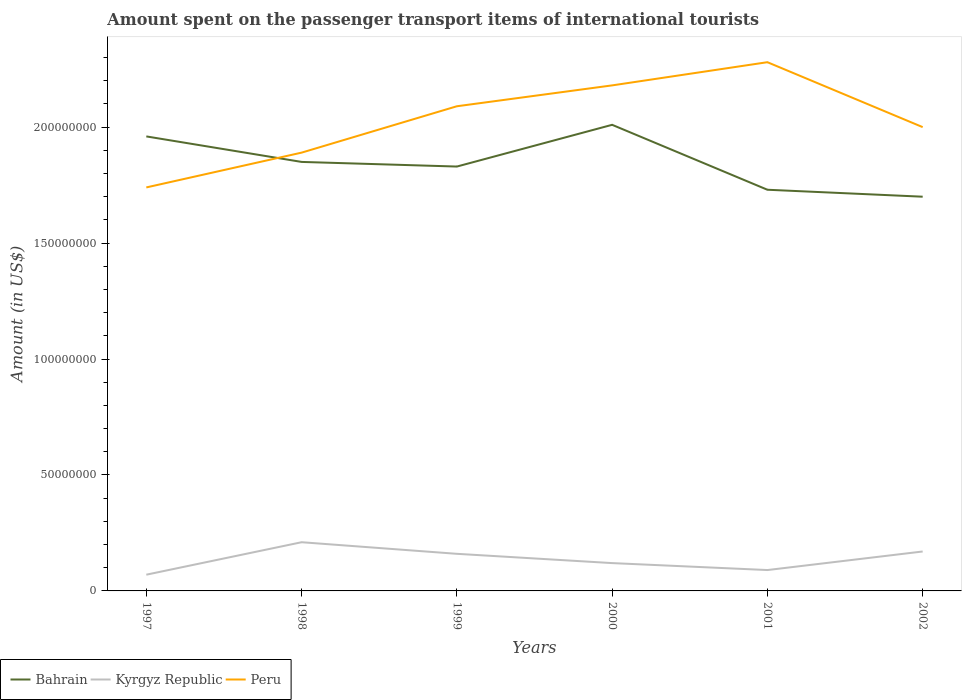How many different coloured lines are there?
Make the answer very short. 3. Does the line corresponding to Bahrain intersect with the line corresponding to Kyrgyz Republic?
Your answer should be very brief. No. Is the number of lines equal to the number of legend labels?
Provide a succinct answer. Yes. Across all years, what is the maximum amount spent on the passenger transport items of international tourists in Peru?
Keep it short and to the point. 1.74e+08. In which year was the amount spent on the passenger transport items of international tourists in Kyrgyz Republic maximum?
Your answer should be very brief. 1997. What is the total amount spent on the passenger transport items of international tourists in Bahrain in the graph?
Your answer should be very brief. 3.10e+07. What is the difference between the highest and the second highest amount spent on the passenger transport items of international tourists in Bahrain?
Your answer should be very brief. 3.10e+07. What is the difference between the highest and the lowest amount spent on the passenger transport items of international tourists in Kyrgyz Republic?
Your answer should be very brief. 3. How many lines are there?
Provide a succinct answer. 3. Are the values on the major ticks of Y-axis written in scientific E-notation?
Your answer should be very brief. No. Does the graph contain any zero values?
Your answer should be very brief. No. Does the graph contain grids?
Provide a short and direct response. No. How many legend labels are there?
Make the answer very short. 3. What is the title of the graph?
Your response must be concise. Amount spent on the passenger transport items of international tourists. Does "Tanzania" appear as one of the legend labels in the graph?
Make the answer very short. No. What is the label or title of the X-axis?
Your response must be concise. Years. What is the label or title of the Y-axis?
Offer a very short reply. Amount (in US$). What is the Amount (in US$) in Bahrain in 1997?
Offer a terse response. 1.96e+08. What is the Amount (in US$) of Kyrgyz Republic in 1997?
Give a very brief answer. 7.00e+06. What is the Amount (in US$) in Peru in 1997?
Give a very brief answer. 1.74e+08. What is the Amount (in US$) of Bahrain in 1998?
Your response must be concise. 1.85e+08. What is the Amount (in US$) in Kyrgyz Republic in 1998?
Ensure brevity in your answer.  2.10e+07. What is the Amount (in US$) in Peru in 1998?
Make the answer very short. 1.89e+08. What is the Amount (in US$) in Bahrain in 1999?
Give a very brief answer. 1.83e+08. What is the Amount (in US$) of Kyrgyz Republic in 1999?
Make the answer very short. 1.60e+07. What is the Amount (in US$) in Peru in 1999?
Offer a very short reply. 2.09e+08. What is the Amount (in US$) in Bahrain in 2000?
Ensure brevity in your answer.  2.01e+08. What is the Amount (in US$) of Kyrgyz Republic in 2000?
Your answer should be compact. 1.20e+07. What is the Amount (in US$) of Peru in 2000?
Your answer should be very brief. 2.18e+08. What is the Amount (in US$) in Bahrain in 2001?
Your answer should be compact. 1.73e+08. What is the Amount (in US$) of Kyrgyz Republic in 2001?
Provide a short and direct response. 9.00e+06. What is the Amount (in US$) of Peru in 2001?
Offer a very short reply. 2.28e+08. What is the Amount (in US$) of Bahrain in 2002?
Offer a terse response. 1.70e+08. What is the Amount (in US$) of Kyrgyz Republic in 2002?
Provide a succinct answer. 1.70e+07. Across all years, what is the maximum Amount (in US$) of Bahrain?
Ensure brevity in your answer.  2.01e+08. Across all years, what is the maximum Amount (in US$) in Kyrgyz Republic?
Your answer should be compact. 2.10e+07. Across all years, what is the maximum Amount (in US$) of Peru?
Keep it short and to the point. 2.28e+08. Across all years, what is the minimum Amount (in US$) of Bahrain?
Your answer should be compact. 1.70e+08. Across all years, what is the minimum Amount (in US$) of Peru?
Give a very brief answer. 1.74e+08. What is the total Amount (in US$) of Bahrain in the graph?
Ensure brevity in your answer.  1.11e+09. What is the total Amount (in US$) in Kyrgyz Republic in the graph?
Offer a very short reply. 8.20e+07. What is the total Amount (in US$) in Peru in the graph?
Ensure brevity in your answer.  1.22e+09. What is the difference between the Amount (in US$) in Bahrain in 1997 and that in 1998?
Offer a very short reply. 1.10e+07. What is the difference between the Amount (in US$) of Kyrgyz Republic in 1997 and that in 1998?
Your response must be concise. -1.40e+07. What is the difference between the Amount (in US$) in Peru in 1997 and that in 1998?
Ensure brevity in your answer.  -1.50e+07. What is the difference between the Amount (in US$) of Bahrain in 1997 and that in 1999?
Your answer should be compact. 1.30e+07. What is the difference between the Amount (in US$) in Kyrgyz Republic in 1997 and that in 1999?
Provide a short and direct response. -9.00e+06. What is the difference between the Amount (in US$) of Peru in 1997 and that in 1999?
Your response must be concise. -3.50e+07. What is the difference between the Amount (in US$) of Bahrain in 1997 and that in 2000?
Your response must be concise. -5.00e+06. What is the difference between the Amount (in US$) in Kyrgyz Republic in 1997 and that in 2000?
Offer a very short reply. -5.00e+06. What is the difference between the Amount (in US$) in Peru in 1997 and that in 2000?
Keep it short and to the point. -4.40e+07. What is the difference between the Amount (in US$) in Bahrain in 1997 and that in 2001?
Ensure brevity in your answer.  2.30e+07. What is the difference between the Amount (in US$) of Peru in 1997 and that in 2001?
Keep it short and to the point. -5.40e+07. What is the difference between the Amount (in US$) in Bahrain in 1997 and that in 2002?
Make the answer very short. 2.60e+07. What is the difference between the Amount (in US$) of Kyrgyz Republic in 1997 and that in 2002?
Offer a very short reply. -1.00e+07. What is the difference between the Amount (in US$) of Peru in 1997 and that in 2002?
Offer a very short reply. -2.60e+07. What is the difference between the Amount (in US$) in Peru in 1998 and that in 1999?
Your answer should be compact. -2.00e+07. What is the difference between the Amount (in US$) of Bahrain in 1998 and that in 2000?
Ensure brevity in your answer.  -1.60e+07. What is the difference between the Amount (in US$) in Kyrgyz Republic in 1998 and that in 2000?
Offer a terse response. 9.00e+06. What is the difference between the Amount (in US$) in Peru in 1998 and that in 2000?
Keep it short and to the point. -2.90e+07. What is the difference between the Amount (in US$) of Peru in 1998 and that in 2001?
Provide a short and direct response. -3.90e+07. What is the difference between the Amount (in US$) of Bahrain in 1998 and that in 2002?
Make the answer very short. 1.50e+07. What is the difference between the Amount (in US$) in Peru in 1998 and that in 2002?
Provide a succinct answer. -1.10e+07. What is the difference between the Amount (in US$) of Bahrain in 1999 and that in 2000?
Your response must be concise. -1.80e+07. What is the difference between the Amount (in US$) of Peru in 1999 and that in 2000?
Offer a very short reply. -9.00e+06. What is the difference between the Amount (in US$) in Kyrgyz Republic in 1999 and that in 2001?
Make the answer very short. 7.00e+06. What is the difference between the Amount (in US$) in Peru in 1999 and that in 2001?
Keep it short and to the point. -1.90e+07. What is the difference between the Amount (in US$) in Bahrain in 1999 and that in 2002?
Offer a very short reply. 1.30e+07. What is the difference between the Amount (in US$) in Peru in 1999 and that in 2002?
Your answer should be very brief. 9.00e+06. What is the difference between the Amount (in US$) in Bahrain in 2000 and that in 2001?
Your response must be concise. 2.80e+07. What is the difference between the Amount (in US$) of Kyrgyz Republic in 2000 and that in 2001?
Keep it short and to the point. 3.00e+06. What is the difference between the Amount (in US$) of Peru in 2000 and that in 2001?
Your response must be concise. -1.00e+07. What is the difference between the Amount (in US$) in Bahrain in 2000 and that in 2002?
Make the answer very short. 3.10e+07. What is the difference between the Amount (in US$) of Kyrgyz Republic in 2000 and that in 2002?
Provide a succinct answer. -5.00e+06. What is the difference between the Amount (in US$) of Peru in 2000 and that in 2002?
Offer a very short reply. 1.80e+07. What is the difference between the Amount (in US$) in Kyrgyz Republic in 2001 and that in 2002?
Give a very brief answer. -8.00e+06. What is the difference between the Amount (in US$) of Peru in 2001 and that in 2002?
Give a very brief answer. 2.80e+07. What is the difference between the Amount (in US$) of Bahrain in 1997 and the Amount (in US$) of Kyrgyz Republic in 1998?
Offer a very short reply. 1.75e+08. What is the difference between the Amount (in US$) in Bahrain in 1997 and the Amount (in US$) in Peru in 1998?
Give a very brief answer. 7.00e+06. What is the difference between the Amount (in US$) in Kyrgyz Republic in 1997 and the Amount (in US$) in Peru in 1998?
Your response must be concise. -1.82e+08. What is the difference between the Amount (in US$) in Bahrain in 1997 and the Amount (in US$) in Kyrgyz Republic in 1999?
Your response must be concise. 1.80e+08. What is the difference between the Amount (in US$) of Bahrain in 1997 and the Amount (in US$) of Peru in 1999?
Provide a succinct answer. -1.30e+07. What is the difference between the Amount (in US$) in Kyrgyz Republic in 1997 and the Amount (in US$) in Peru in 1999?
Offer a very short reply. -2.02e+08. What is the difference between the Amount (in US$) of Bahrain in 1997 and the Amount (in US$) of Kyrgyz Republic in 2000?
Offer a terse response. 1.84e+08. What is the difference between the Amount (in US$) in Bahrain in 1997 and the Amount (in US$) in Peru in 2000?
Keep it short and to the point. -2.20e+07. What is the difference between the Amount (in US$) in Kyrgyz Republic in 1997 and the Amount (in US$) in Peru in 2000?
Your answer should be compact. -2.11e+08. What is the difference between the Amount (in US$) in Bahrain in 1997 and the Amount (in US$) in Kyrgyz Republic in 2001?
Provide a succinct answer. 1.87e+08. What is the difference between the Amount (in US$) of Bahrain in 1997 and the Amount (in US$) of Peru in 2001?
Give a very brief answer. -3.20e+07. What is the difference between the Amount (in US$) in Kyrgyz Republic in 1997 and the Amount (in US$) in Peru in 2001?
Make the answer very short. -2.21e+08. What is the difference between the Amount (in US$) in Bahrain in 1997 and the Amount (in US$) in Kyrgyz Republic in 2002?
Your response must be concise. 1.79e+08. What is the difference between the Amount (in US$) in Kyrgyz Republic in 1997 and the Amount (in US$) in Peru in 2002?
Give a very brief answer. -1.93e+08. What is the difference between the Amount (in US$) of Bahrain in 1998 and the Amount (in US$) of Kyrgyz Republic in 1999?
Make the answer very short. 1.69e+08. What is the difference between the Amount (in US$) in Bahrain in 1998 and the Amount (in US$) in Peru in 1999?
Your answer should be compact. -2.40e+07. What is the difference between the Amount (in US$) of Kyrgyz Republic in 1998 and the Amount (in US$) of Peru in 1999?
Offer a very short reply. -1.88e+08. What is the difference between the Amount (in US$) in Bahrain in 1998 and the Amount (in US$) in Kyrgyz Republic in 2000?
Make the answer very short. 1.73e+08. What is the difference between the Amount (in US$) in Bahrain in 1998 and the Amount (in US$) in Peru in 2000?
Provide a short and direct response. -3.30e+07. What is the difference between the Amount (in US$) in Kyrgyz Republic in 1998 and the Amount (in US$) in Peru in 2000?
Make the answer very short. -1.97e+08. What is the difference between the Amount (in US$) of Bahrain in 1998 and the Amount (in US$) of Kyrgyz Republic in 2001?
Ensure brevity in your answer.  1.76e+08. What is the difference between the Amount (in US$) of Bahrain in 1998 and the Amount (in US$) of Peru in 2001?
Provide a succinct answer. -4.30e+07. What is the difference between the Amount (in US$) of Kyrgyz Republic in 1998 and the Amount (in US$) of Peru in 2001?
Provide a succinct answer. -2.07e+08. What is the difference between the Amount (in US$) in Bahrain in 1998 and the Amount (in US$) in Kyrgyz Republic in 2002?
Ensure brevity in your answer.  1.68e+08. What is the difference between the Amount (in US$) in Bahrain in 1998 and the Amount (in US$) in Peru in 2002?
Ensure brevity in your answer.  -1.50e+07. What is the difference between the Amount (in US$) in Kyrgyz Republic in 1998 and the Amount (in US$) in Peru in 2002?
Make the answer very short. -1.79e+08. What is the difference between the Amount (in US$) of Bahrain in 1999 and the Amount (in US$) of Kyrgyz Republic in 2000?
Your answer should be very brief. 1.71e+08. What is the difference between the Amount (in US$) of Bahrain in 1999 and the Amount (in US$) of Peru in 2000?
Offer a terse response. -3.50e+07. What is the difference between the Amount (in US$) of Kyrgyz Republic in 1999 and the Amount (in US$) of Peru in 2000?
Provide a succinct answer. -2.02e+08. What is the difference between the Amount (in US$) in Bahrain in 1999 and the Amount (in US$) in Kyrgyz Republic in 2001?
Give a very brief answer. 1.74e+08. What is the difference between the Amount (in US$) of Bahrain in 1999 and the Amount (in US$) of Peru in 2001?
Your response must be concise. -4.50e+07. What is the difference between the Amount (in US$) of Kyrgyz Republic in 1999 and the Amount (in US$) of Peru in 2001?
Ensure brevity in your answer.  -2.12e+08. What is the difference between the Amount (in US$) in Bahrain in 1999 and the Amount (in US$) in Kyrgyz Republic in 2002?
Offer a terse response. 1.66e+08. What is the difference between the Amount (in US$) of Bahrain in 1999 and the Amount (in US$) of Peru in 2002?
Make the answer very short. -1.70e+07. What is the difference between the Amount (in US$) of Kyrgyz Republic in 1999 and the Amount (in US$) of Peru in 2002?
Your answer should be compact. -1.84e+08. What is the difference between the Amount (in US$) in Bahrain in 2000 and the Amount (in US$) in Kyrgyz Republic in 2001?
Keep it short and to the point. 1.92e+08. What is the difference between the Amount (in US$) of Bahrain in 2000 and the Amount (in US$) of Peru in 2001?
Your answer should be compact. -2.70e+07. What is the difference between the Amount (in US$) in Kyrgyz Republic in 2000 and the Amount (in US$) in Peru in 2001?
Your answer should be compact. -2.16e+08. What is the difference between the Amount (in US$) of Bahrain in 2000 and the Amount (in US$) of Kyrgyz Republic in 2002?
Offer a very short reply. 1.84e+08. What is the difference between the Amount (in US$) in Bahrain in 2000 and the Amount (in US$) in Peru in 2002?
Give a very brief answer. 1.00e+06. What is the difference between the Amount (in US$) in Kyrgyz Republic in 2000 and the Amount (in US$) in Peru in 2002?
Provide a succinct answer. -1.88e+08. What is the difference between the Amount (in US$) in Bahrain in 2001 and the Amount (in US$) in Kyrgyz Republic in 2002?
Give a very brief answer. 1.56e+08. What is the difference between the Amount (in US$) of Bahrain in 2001 and the Amount (in US$) of Peru in 2002?
Keep it short and to the point. -2.70e+07. What is the difference between the Amount (in US$) in Kyrgyz Republic in 2001 and the Amount (in US$) in Peru in 2002?
Keep it short and to the point. -1.91e+08. What is the average Amount (in US$) in Bahrain per year?
Your answer should be compact. 1.85e+08. What is the average Amount (in US$) of Kyrgyz Republic per year?
Keep it short and to the point. 1.37e+07. What is the average Amount (in US$) in Peru per year?
Give a very brief answer. 2.03e+08. In the year 1997, what is the difference between the Amount (in US$) of Bahrain and Amount (in US$) of Kyrgyz Republic?
Keep it short and to the point. 1.89e+08. In the year 1997, what is the difference between the Amount (in US$) in Bahrain and Amount (in US$) in Peru?
Ensure brevity in your answer.  2.20e+07. In the year 1997, what is the difference between the Amount (in US$) in Kyrgyz Republic and Amount (in US$) in Peru?
Ensure brevity in your answer.  -1.67e+08. In the year 1998, what is the difference between the Amount (in US$) of Bahrain and Amount (in US$) of Kyrgyz Republic?
Provide a succinct answer. 1.64e+08. In the year 1998, what is the difference between the Amount (in US$) of Bahrain and Amount (in US$) of Peru?
Your answer should be compact. -4.00e+06. In the year 1998, what is the difference between the Amount (in US$) of Kyrgyz Republic and Amount (in US$) of Peru?
Provide a succinct answer. -1.68e+08. In the year 1999, what is the difference between the Amount (in US$) of Bahrain and Amount (in US$) of Kyrgyz Republic?
Offer a terse response. 1.67e+08. In the year 1999, what is the difference between the Amount (in US$) of Bahrain and Amount (in US$) of Peru?
Provide a short and direct response. -2.60e+07. In the year 1999, what is the difference between the Amount (in US$) in Kyrgyz Republic and Amount (in US$) in Peru?
Your answer should be compact. -1.93e+08. In the year 2000, what is the difference between the Amount (in US$) in Bahrain and Amount (in US$) in Kyrgyz Republic?
Keep it short and to the point. 1.89e+08. In the year 2000, what is the difference between the Amount (in US$) of Bahrain and Amount (in US$) of Peru?
Give a very brief answer. -1.70e+07. In the year 2000, what is the difference between the Amount (in US$) of Kyrgyz Republic and Amount (in US$) of Peru?
Provide a short and direct response. -2.06e+08. In the year 2001, what is the difference between the Amount (in US$) of Bahrain and Amount (in US$) of Kyrgyz Republic?
Ensure brevity in your answer.  1.64e+08. In the year 2001, what is the difference between the Amount (in US$) in Bahrain and Amount (in US$) in Peru?
Ensure brevity in your answer.  -5.50e+07. In the year 2001, what is the difference between the Amount (in US$) of Kyrgyz Republic and Amount (in US$) of Peru?
Provide a short and direct response. -2.19e+08. In the year 2002, what is the difference between the Amount (in US$) in Bahrain and Amount (in US$) in Kyrgyz Republic?
Provide a short and direct response. 1.53e+08. In the year 2002, what is the difference between the Amount (in US$) of Bahrain and Amount (in US$) of Peru?
Keep it short and to the point. -3.00e+07. In the year 2002, what is the difference between the Amount (in US$) in Kyrgyz Republic and Amount (in US$) in Peru?
Your answer should be compact. -1.83e+08. What is the ratio of the Amount (in US$) in Bahrain in 1997 to that in 1998?
Your answer should be very brief. 1.06. What is the ratio of the Amount (in US$) of Kyrgyz Republic in 1997 to that in 1998?
Offer a very short reply. 0.33. What is the ratio of the Amount (in US$) in Peru in 1997 to that in 1998?
Make the answer very short. 0.92. What is the ratio of the Amount (in US$) of Bahrain in 1997 to that in 1999?
Make the answer very short. 1.07. What is the ratio of the Amount (in US$) in Kyrgyz Republic in 1997 to that in 1999?
Give a very brief answer. 0.44. What is the ratio of the Amount (in US$) in Peru in 1997 to that in 1999?
Ensure brevity in your answer.  0.83. What is the ratio of the Amount (in US$) of Bahrain in 1997 to that in 2000?
Keep it short and to the point. 0.98. What is the ratio of the Amount (in US$) in Kyrgyz Republic in 1997 to that in 2000?
Offer a very short reply. 0.58. What is the ratio of the Amount (in US$) in Peru in 1997 to that in 2000?
Offer a very short reply. 0.8. What is the ratio of the Amount (in US$) of Bahrain in 1997 to that in 2001?
Offer a terse response. 1.13. What is the ratio of the Amount (in US$) in Kyrgyz Republic in 1997 to that in 2001?
Make the answer very short. 0.78. What is the ratio of the Amount (in US$) in Peru in 1997 to that in 2001?
Your answer should be compact. 0.76. What is the ratio of the Amount (in US$) of Bahrain in 1997 to that in 2002?
Make the answer very short. 1.15. What is the ratio of the Amount (in US$) of Kyrgyz Republic in 1997 to that in 2002?
Provide a short and direct response. 0.41. What is the ratio of the Amount (in US$) in Peru in 1997 to that in 2002?
Keep it short and to the point. 0.87. What is the ratio of the Amount (in US$) of Bahrain in 1998 to that in 1999?
Offer a terse response. 1.01. What is the ratio of the Amount (in US$) in Kyrgyz Republic in 1998 to that in 1999?
Provide a succinct answer. 1.31. What is the ratio of the Amount (in US$) of Peru in 1998 to that in 1999?
Provide a short and direct response. 0.9. What is the ratio of the Amount (in US$) of Bahrain in 1998 to that in 2000?
Offer a terse response. 0.92. What is the ratio of the Amount (in US$) in Peru in 1998 to that in 2000?
Your answer should be very brief. 0.87. What is the ratio of the Amount (in US$) of Bahrain in 1998 to that in 2001?
Keep it short and to the point. 1.07. What is the ratio of the Amount (in US$) in Kyrgyz Republic in 1998 to that in 2001?
Make the answer very short. 2.33. What is the ratio of the Amount (in US$) in Peru in 1998 to that in 2001?
Offer a very short reply. 0.83. What is the ratio of the Amount (in US$) in Bahrain in 1998 to that in 2002?
Your response must be concise. 1.09. What is the ratio of the Amount (in US$) in Kyrgyz Republic in 1998 to that in 2002?
Your answer should be very brief. 1.24. What is the ratio of the Amount (in US$) in Peru in 1998 to that in 2002?
Offer a terse response. 0.94. What is the ratio of the Amount (in US$) in Bahrain in 1999 to that in 2000?
Your answer should be compact. 0.91. What is the ratio of the Amount (in US$) of Kyrgyz Republic in 1999 to that in 2000?
Ensure brevity in your answer.  1.33. What is the ratio of the Amount (in US$) in Peru in 1999 to that in 2000?
Your answer should be compact. 0.96. What is the ratio of the Amount (in US$) in Bahrain in 1999 to that in 2001?
Provide a short and direct response. 1.06. What is the ratio of the Amount (in US$) in Kyrgyz Republic in 1999 to that in 2001?
Your answer should be compact. 1.78. What is the ratio of the Amount (in US$) of Bahrain in 1999 to that in 2002?
Your answer should be very brief. 1.08. What is the ratio of the Amount (in US$) of Kyrgyz Republic in 1999 to that in 2002?
Provide a succinct answer. 0.94. What is the ratio of the Amount (in US$) of Peru in 1999 to that in 2002?
Offer a very short reply. 1.04. What is the ratio of the Amount (in US$) of Bahrain in 2000 to that in 2001?
Offer a very short reply. 1.16. What is the ratio of the Amount (in US$) in Kyrgyz Republic in 2000 to that in 2001?
Ensure brevity in your answer.  1.33. What is the ratio of the Amount (in US$) of Peru in 2000 to that in 2001?
Give a very brief answer. 0.96. What is the ratio of the Amount (in US$) of Bahrain in 2000 to that in 2002?
Make the answer very short. 1.18. What is the ratio of the Amount (in US$) in Kyrgyz Republic in 2000 to that in 2002?
Your answer should be compact. 0.71. What is the ratio of the Amount (in US$) of Peru in 2000 to that in 2002?
Ensure brevity in your answer.  1.09. What is the ratio of the Amount (in US$) in Bahrain in 2001 to that in 2002?
Your response must be concise. 1.02. What is the ratio of the Amount (in US$) of Kyrgyz Republic in 2001 to that in 2002?
Your response must be concise. 0.53. What is the ratio of the Amount (in US$) in Peru in 2001 to that in 2002?
Your answer should be very brief. 1.14. What is the difference between the highest and the second highest Amount (in US$) of Kyrgyz Republic?
Give a very brief answer. 4.00e+06. What is the difference between the highest and the second highest Amount (in US$) in Peru?
Make the answer very short. 1.00e+07. What is the difference between the highest and the lowest Amount (in US$) in Bahrain?
Make the answer very short. 3.10e+07. What is the difference between the highest and the lowest Amount (in US$) of Kyrgyz Republic?
Provide a short and direct response. 1.40e+07. What is the difference between the highest and the lowest Amount (in US$) of Peru?
Your answer should be compact. 5.40e+07. 